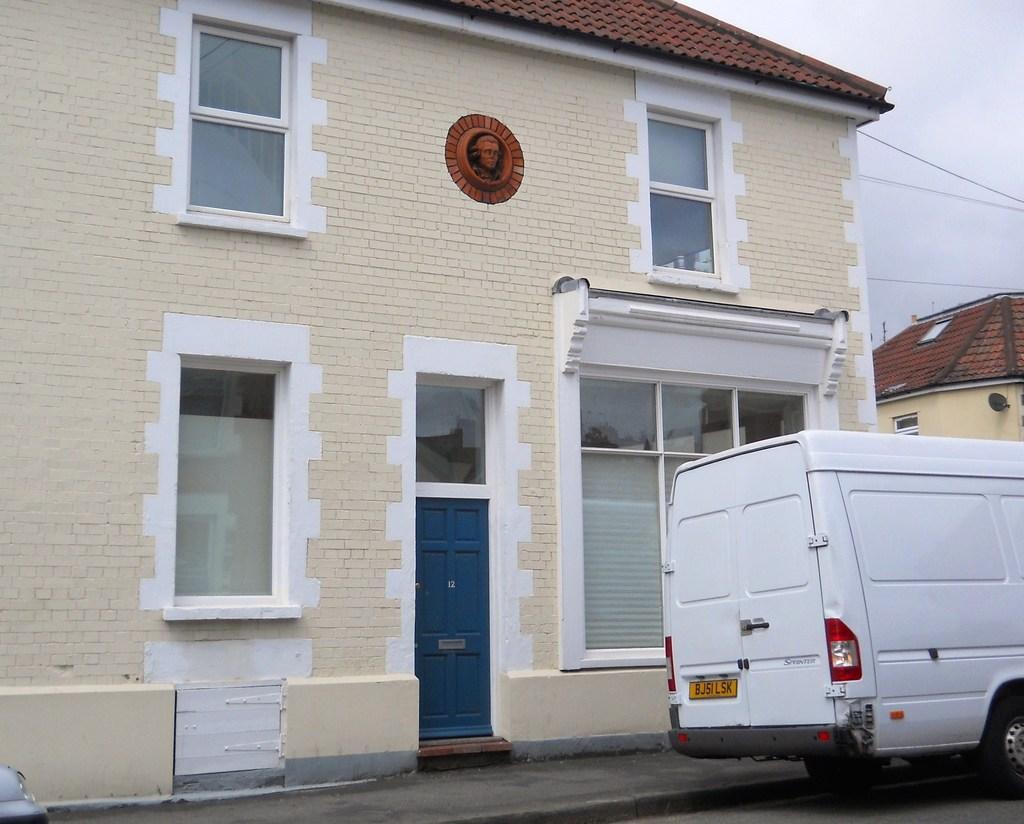Could you give a brief overview of what you see in this image? In this image we can see a house with windows, door. There is a depiction of a person on it. To the right side of the image there is a house. There is a vehicle on the road. 